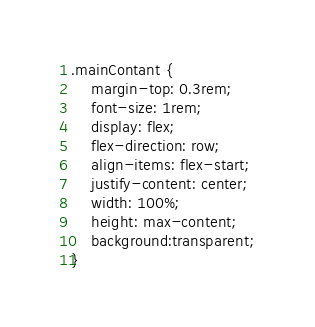<code> <loc_0><loc_0><loc_500><loc_500><_CSS_>
.mainContant {
    margin-top: 0.3rem;
    font-size: 1rem;
    display: flex;
    flex-direction: row;
    align-items: flex-start;
    justify-content: center;
    width: 100%;
    height: max-content;
    background:transparent;
}


</code> 